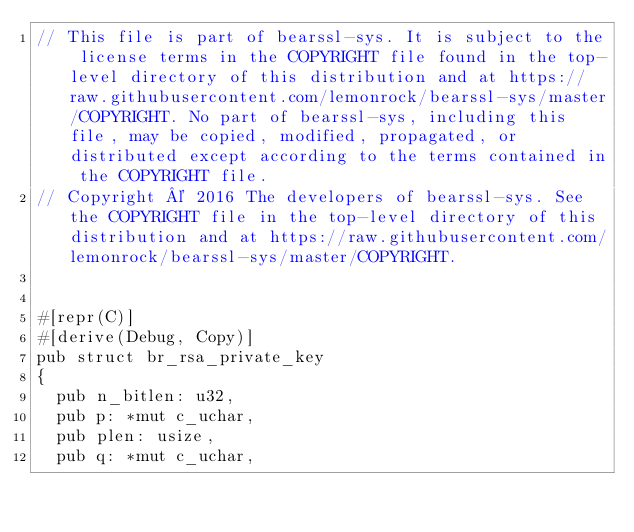<code> <loc_0><loc_0><loc_500><loc_500><_Rust_>// This file is part of bearssl-sys. It is subject to the license terms in the COPYRIGHT file found in the top-level directory of this distribution and at https://raw.githubusercontent.com/lemonrock/bearssl-sys/master/COPYRIGHT. No part of bearssl-sys, including this file, may be copied, modified, propagated, or distributed except according to the terms contained in the COPYRIGHT file.
// Copyright © 2016 The developers of bearssl-sys. See the COPYRIGHT file in the top-level directory of this distribution and at https://raw.githubusercontent.com/lemonrock/bearssl-sys/master/COPYRIGHT.


#[repr(C)]
#[derive(Debug, Copy)]
pub struct br_rsa_private_key
{
	pub n_bitlen: u32,
	pub p: *mut c_uchar,
	pub plen: usize,
	pub q: *mut c_uchar,</code> 